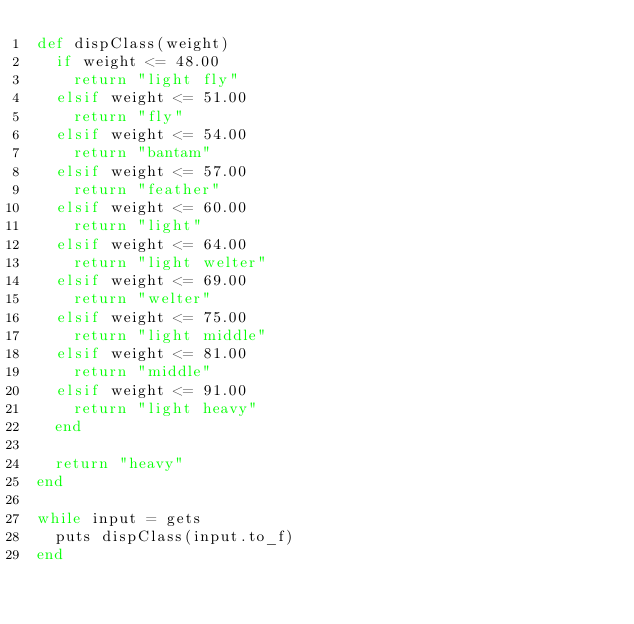Convert code to text. <code><loc_0><loc_0><loc_500><loc_500><_Ruby_>def dispClass(weight)
  if weight <= 48.00
    return "light fly"
  elsif weight <= 51.00
    return "fly"
  elsif weight <= 54.00
    return "bantam"
  elsif weight <= 57.00
    return "feather"
  elsif weight <= 60.00
    return "light"
  elsif weight <= 64.00
    return "light welter"
  elsif weight <= 69.00
    return "welter"
  elsif weight <= 75.00
    return "light middle"
  elsif weight <= 81.00
    return "middle"
  elsif weight <= 91.00
    return "light heavy"
  end

  return "heavy"
end

while input = gets
  puts dispClass(input.to_f)
end</code> 